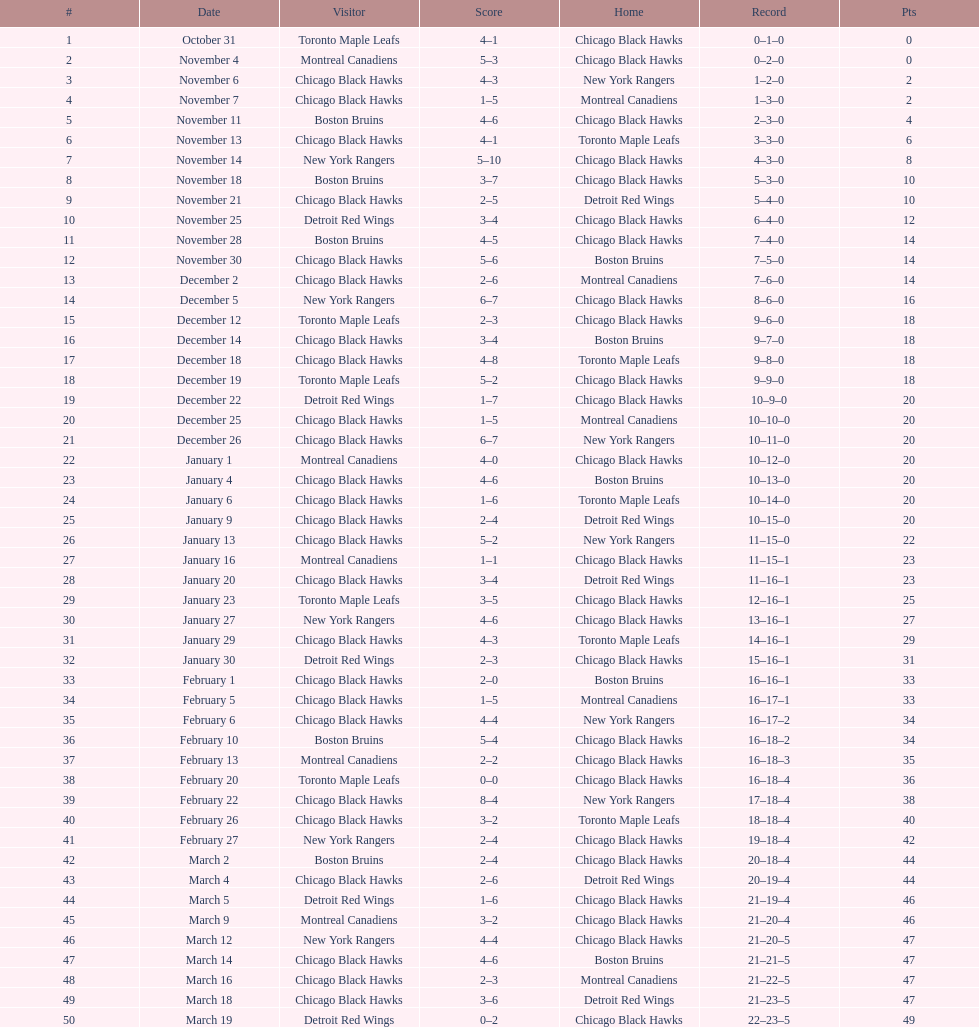Following november 11, who was the subsequent team to face the boston bruins? Chicago Black Hawks. 